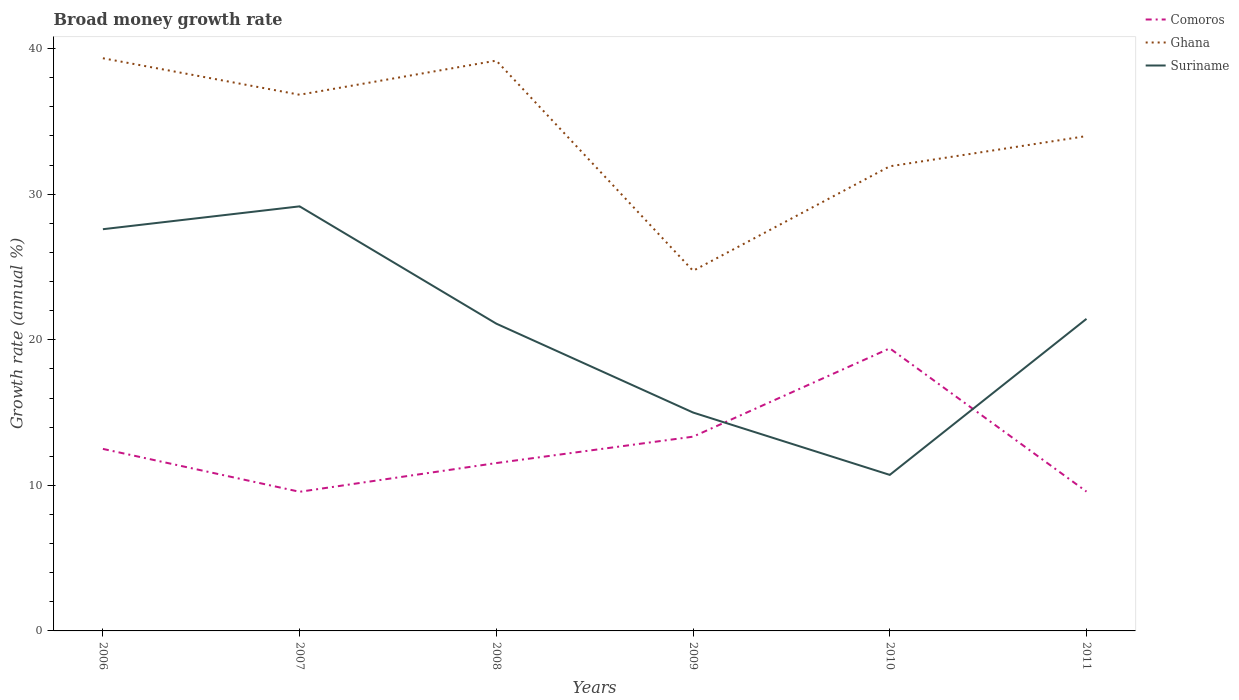Is the number of lines equal to the number of legend labels?
Offer a very short reply. Yes. Across all years, what is the maximum growth rate in Suriname?
Ensure brevity in your answer.  10.72. What is the total growth rate in Ghana in the graph?
Make the answer very short. 0.16. What is the difference between the highest and the second highest growth rate in Ghana?
Your answer should be very brief. 14.6. What is the difference between the highest and the lowest growth rate in Comoros?
Your answer should be very brief. 2. Is the growth rate in Ghana strictly greater than the growth rate in Suriname over the years?
Keep it short and to the point. No. Are the values on the major ticks of Y-axis written in scientific E-notation?
Offer a terse response. No. Does the graph contain any zero values?
Provide a succinct answer. No. How many legend labels are there?
Your answer should be compact. 3. What is the title of the graph?
Keep it short and to the point. Broad money growth rate. What is the label or title of the Y-axis?
Ensure brevity in your answer.  Growth rate (annual %). What is the Growth rate (annual %) in Comoros in 2006?
Provide a succinct answer. 12.5. What is the Growth rate (annual %) in Ghana in 2006?
Offer a terse response. 39.34. What is the Growth rate (annual %) in Suriname in 2006?
Offer a terse response. 27.6. What is the Growth rate (annual %) of Comoros in 2007?
Offer a very short reply. 9.56. What is the Growth rate (annual %) in Ghana in 2007?
Your answer should be very brief. 36.83. What is the Growth rate (annual %) of Suriname in 2007?
Offer a terse response. 29.17. What is the Growth rate (annual %) in Comoros in 2008?
Provide a succinct answer. 11.53. What is the Growth rate (annual %) of Ghana in 2008?
Ensure brevity in your answer.  39.18. What is the Growth rate (annual %) in Suriname in 2008?
Your answer should be compact. 21.11. What is the Growth rate (annual %) in Comoros in 2009?
Give a very brief answer. 13.34. What is the Growth rate (annual %) in Ghana in 2009?
Offer a very short reply. 24.74. What is the Growth rate (annual %) in Suriname in 2009?
Give a very brief answer. 15. What is the Growth rate (annual %) of Comoros in 2010?
Your answer should be compact. 19.41. What is the Growth rate (annual %) of Ghana in 2010?
Offer a very short reply. 31.92. What is the Growth rate (annual %) in Suriname in 2010?
Keep it short and to the point. 10.72. What is the Growth rate (annual %) in Comoros in 2011?
Ensure brevity in your answer.  9.57. What is the Growth rate (annual %) in Ghana in 2011?
Keep it short and to the point. 33.99. What is the Growth rate (annual %) in Suriname in 2011?
Ensure brevity in your answer.  21.44. Across all years, what is the maximum Growth rate (annual %) in Comoros?
Your answer should be compact. 19.41. Across all years, what is the maximum Growth rate (annual %) of Ghana?
Your response must be concise. 39.34. Across all years, what is the maximum Growth rate (annual %) in Suriname?
Give a very brief answer. 29.17. Across all years, what is the minimum Growth rate (annual %) of Comoros?
Offer a very short reply. 9.56. Across all years, what is the minimum Growth rate (annual %) of Ghana?
Give a very brief answer. 24.74. Across all years, what is the minimum Growth rate (annual %) of Suriname?
Your answer should be compact. 10.72. What is the total Growth rate (annual %) in Comoros in the graph?
Your answer should be compact. 75.92. What is the total Growth rate (annual %) in Ghana in the graph?
Your answer should be compact. 206. What is the total Growth rate (annual %) of Suriname in the graph?
Your answer should be very brief. 125.03. What is the difference between the Growth rate (annual %) in Comoros in 2006 and that in 2007?
Give a very brief answer. 2.95. What is the difference between the Growth rate (annual %) of Ghana in 2006 and that in 2007?
Ensure brevity in your answer.  2.51. What is the difference between the Growth rate (annual %) in Suriname in 2006 and that in 2007?
Provide a succinct answer. -1.57. What is the difference between the Growth rate (annual %) in Comoros in 2006 and that in 2008?
Your answer should be compact. 0.97. What is the difference between the Growth rate (annual %) of Ghana in 2006 and that in 2008?
Your answer should be very brief. 0.16. What is the difference between the Growth rate (annual %) in Suriname in 2006 and that in 2008?
Provide a short and direct response. 6.49. What is the difference between the Growth rate (annual %) in Comoros in 2006 and that in 2009?
Offer a very short reply. -0.84. What is the difference between the Growth rate (annual %) in Ghana in 2006 and that in 2009?
Your answer should be very brief. 14.6. What is the difference between the Growth rate (annual %) of Suriname in 2006 and that in 2009?
Give a very brief answer. 12.59. What is the difference between the Growth rate (annual %) in Comoros in 2006 and that in 2010?
Your response must be concise. -6.91. What is the difference between the Growth rate (annual %) in Ghana in 2006 and that in 2010?
Offer a very short reply. 7.42. What is the difference between the Growth rate (annual %) of Suriname in 2006 and that in 2010?
Offer a very short reply. 16.88. What is the difference between the Growth rate (annual %) of Comoros in 2006 and that in 2011?
Your response must be concise. 2.93. What is the difference between the Growth rate (annual %) in Ghana in 2006 and that in 2011?
Your response must be concise. 5.35. What is the difference between the Growth rate (annual %) of Suriname in 2006 and that in 2011?
Make the answer very short. 6.16. What is the difference between the Growth rate (annual %) of Comoros in 2007 and that in 2008?
Keep it short and to the point. -1.97. What is the difference between the Growth rate (annual %) of Ghana in 2007 and that in 2008?
Give a very brief answer. -2.34. What is the difference between the Growth rate (annual %) in Suriname in 2007 and that in 2008?
Keep it short and to the point. 8.06. What is the difference between the Growth rate (annual %) of Comoros in 2007 and that in 2009?
Offer a very short reply. -3.79. What is the difference between the Growth rate (annual %) in Ghana in 2007 and that in 2009?
Provide a succinct answer. 12.1. What is the difference between the Growth rate (annual %) of Suriname in 2007 and that in 2009?
Give a very brief answer. 14.16. What is the difference between the Growth rate (annual %) in Comoros in 2007 and that in 2010?
Ensure brevity in your answer.  -9.85. What is the difference between the Growth rate (annual %) of Ghana in 2007 and that in 2010?
Provide a succinct answer. 4.92. What is the difference between the Growth rate (annual %) of Suriname in 2007 and that in 2010?
Keep it short and to the point. 18.45. What is the difference between the Growth rate (annual %) of Comoros in 2007 and that in 2011?
Your answer should be compact. -0.01. What is the difference between the Growth rate (annual %) in Ghana in 2007 and that in 2011?
Offer a very short reply. 2.84. What is the difference between the Growth rate (annual %) in Suriname in 2007 and that in 2011?
Your answer should be very brief. 7.73. What is the difference between the Growth rate (annual %) of Comoros in 2008 and that in 2009?
Your answer should be compact. -1.81. What is the difference between the Growth rate (annual %) in Ghana in 2008 and that in 2009?
Keep it short and to the point. 14.44. What is the difference between the Growth rate (annual %) of Suriname in 2008 and that in 2009?
Provide a succinct answer. 6.1. What is the difference between the Growth rate (annual %) of Comoros in 2008 and that in 2010?
Make the answer very short. -7.88. What is the difference between the Growth rate (annual %) in Ghana in 2008 and that in 2010?
Offer a very short reply. 7.26. What is the difference between the Growth rate (annual %) in Suriname in 2008 and that in 2010?
Give a very brief answer. 10.39. What is the difference between the Growth rate (annual %) of Comoros in 2008 and that in 2011?
Offer a very short reply. 1.96. What is the difference between the Growth rate (annual %) of Ghana in 2008 and that in 2011?
Your response must be concise. 5.18. What is the difference between the Growth rate (annual %) of Suriname in 2008 and that in 2011?
Keep it short and to the point. -0.33. What is the difference between the Growth rate (annual %) in Comoros in 2009 and that in 2010?
Make the answer very short. -6.07. What is the difference between the Growth rate (annual %) of Ghana in 2009 and that in 2010?
Make the answer very short. -7.18. What is the difference between the Growth rate (annual %) in Suriname in 2009 and that in 2010?
Your response must be concise. 4.28. What is the difference between the Growth rate (annual %) in Comoros in 2009 and that in 2011?
Offer a very short reply. 3.77. What is the difference between the Growth rate (annual %) of Ghana in 2009 and that in 2011?
Your answer should be very brief. -9.26. What is the difference between the Growth rate (annual %) of Suriname in 2009 and that in 2011?
Your response must be concise. -6.43. What is the difference between the Growth rate (annual %) of Comoros in 2010 and that in 2011?
Provide a short and direct response. 9.84. What is the difference between the Growth rate (annual %) of Ghana in 2010 and that in 2011?
Offer a very short reply. -2.08. What is the difference between the Growth rate (annual %) of Suriname in 2010 and that in 2011?
Give a very brief answer. -10.72. What is the difference between the Growth rate (annual %) of Comoros in 2006 and the Growth rate (annual %) of Ghana in 2007?
Ensure brevity in your answer.  -24.33. What is the difference between the Growth rate (annual %) in Comoros in 2006 and the Growth rate (annual %) in Suriname in 2007?
Your answer should be very brief. -16.66. What is the difference between the Growth rate (annual %) in Ghana in 2006 and the Growth rate (annual %) in Suriname in 2007?
Ensure brevity in your answer.  10.17. What is the difference between the Growth rate (annual %) in Comoros in 2006 and the Growth rate (annual %) in Ghana in 2008?
Provide a short and direct response. -26.67. What is the difference between the Growth rate (annual %) in Comoros in 2006 and the Growth rate (annual %) in Suriname in 2008?
Your answer should be compact. -8.6. What is the difference between the Growth rate (annual %) in Ghana in 2006 and the Growth rate (annual %) in Suriname in 2008?
Your response must be concise. 18.23. What is the difference between the Growth rate (annual %) of Comoros in 2006 and the Growth rate (annual %) of Ghana in 2009?
Provide a succinct answer. -12.23. What is the difference between the Growth rate (annual %) in Comoros in 2006 and the Growth rate (annual %) in Suriname in 2009?
Make the answer very short. -2.5. What is the difference between the Growth rate (annual %) in Ghana in 2006 and the Growth rate (annual %) in Suriname in 2009?
Give a very brief answer. 24.34. What is the difference between the Growth rate (annual %) of Comoros in 2006 and the Growth rate (annual %) of Ghana in 2010?
Your answer should be very brief. -19.41. What is the difference between the Growth rate (annual %) in Comoros in 2006 and the Growth rate (annual %) in Suriname in 2010?
Offer a terse response. 1.78. What is the difference between the Growth rate (annual %) in Ghana in 2006 and the Growth rate (annual %) in Suriname in 2010?
Keep it short and to the point. 28.62. What is the difference between the Growth rate (annual %) of Comoros in 2006 and the Growth rate (annual %) of Ghana in 2011?
Offer a very short reply. -21.49. What is the difference between the Growth rate (annual %) in Comoros in 2006 and the Growth rate (annual %) in Suriname in 2011?
Provide a succinct answer. -8.93. What is the difference between the Growth rate (annual %) in Ghana in 2006 and the Growth rate (annual %) in Suriname in 2011?
Your answer should be compact. 17.9. What is the difference between the Growth rate (annual %) of Comoros in 2007 and the Growth rate (annual %) of Ghana in 2008?
Your response must be concise. -29.62. What is the difference between the Growth rate (annual %) in Comoros in 2007 and the Growth rate (annual %) in Suriname in 2008?
Ensure brevity in your answer.  -11.55. What is the difference between the Growth rate (annual %) of Ghana in 2007 and the Growth rate (annual %) of Suriname in 2008?
Make the answer very short. 15.73. What is the difference between the Growth rate (annual %) of Comoros in 2007 and the Growth rate (annual %) of Ghana in 2009?
Your answer should be very brief. -15.18. What is the difference between the Growth rate (annual %) in Comoros in 2007 and the Growth rate (annual %) in Suriname in 2009?
Give a very brief answer. -5.44. What is the difference between the Growth rate (annual %) in Ghana in 2007 and the Growth rate (annual %) in Suriname in 2009?
Offer a terse response. 21.83. What is the difference between the Growth rate (annual %) of Comoros in 2007 and the Growth rate (annual %) of Ghana in 2010?
Offer a terse response. -22.36. What is the difference between the Growth rate (annual %) in Comoros in 2007 and the Growth rate (annual %) in Suriname in 2010?
Keep it short and to the point. -1.16. What is the difference between the Growth rate (annual %) in Ghana in 2007 and the Growth rate (annual %) in Suriname in 2010?
Give a very brief answer. 26.12. What is the difference between the Growth rate (annual %) in Comoros in 2007 and the Growth rate (annual %) in Ghana in 2011?
Offer a terse response. -24.44. What is the difference between the Growth rate (annual %) in Comoros in 2007 and the Growth rate (annual %) in Suriname in 2011?
Make the answer very short. -11.88. What is the difference between the Growth rate (annual %) in Ghana in 2007 and the Growth rate (annual %) in Suriname in 2011?
Provide a short and direct response. 15.4. What is the difference between the Growth rate (annual %) of Comoros in 2008 and the Growth rate (annual %) of Ghana in 2009?
Your answer should be very brief. -13.21. What is the difference between the Growth rate (annual %) of Comoros in 2008 and the Growth rate (annual %) of Suriname in 2009?
Offer a very short reply. -3.47. What is the difference between the Growth rate (annual %) in Ghana in 2008 and the Growth rate (annual %) in Suriname in 2009?
Offer a terse response. 24.18. What is the difference between the Growth rate (annual %) of Comoros in 2008 and the Growth rate (annual %) of Ghana in 2010?
Offer a terse response. -20.39. What is the difference between the Growth rate (annual %) in Comoros in 2008 and the Growth rate (annual %) in Suriname in 2010?
Provide a short and direct response. 0.81. What is the difference between the Growth rate (annual %) in Ghana in 2008 and the Growth rate (annual %) in Suriname in 2010?
Your answer should be compact. 28.46. What is the difference between the Growth rate (annual %) of Comoros in 2008 and the Growth rate (annual %) of Ghana in 2011?
Make the answer very short. -22.46. What is the difference between the Growth rate (annual %) of Comoros in 2008 and the Growth rate (annual %) of Suriname in 2011?
Your answer should be compact. -9.91. What is the difference between the Growth rate (annual %) in Ghana in 2008 and the Growth rate (annual %) in Suriname in 2011?
Offer a very short reply. 17.74. What is the difference between the Growth rate (annual %) in Comoros in 2009 and the Growth rate (annual %) in Ghana in 2010?
Make the answer very short. -18.57. What is the difference between the Growth rate (annual %) in Comoros in 2009 and the Growth rate (annual %) in Suriname in 2010?
Make the answer very short. 2.63. What is the difference between the Growth rate (annual %) of Ghana in 2009 and the Growth rate (annual %) of Suriname in 2010?
Provide a succinct answer. 14.02. What is the difference between the Growth rate (annual %) in Comoros in 2009 and the Growth rate (annual %) in Ghana in 2011?
Your answer should be compact. -20.65. What is the difference between the Growth rate (annual %) of Comoros in 2009 and the Growth rate (annual %) of Suriname in 2011?
Ensure brevity in your answer.  -8.09. What is the difference between the Growth rate (annual %) of Ghana in 2009 and the Growth rate (annual %) of Suriname in 2011?
Ensure brevity in your answer.  3.3. What is the difference between the Growth rate (annual %) of Comoros in 2010 and the Growth rate (annual %) of Ghana in 2011?
Keep it short and to the point. -14.58. What is the difference between the Growth rate (annual %) of Comoros in 2010 and the Growth rate (annual %) of Suriname in 2011?
Provide a succinct answer. -2.03. What is the difference between the Growth rate (annual %) in Ghana in 2010 and the Growth rate (annual %) in Suriname in 2011?
Ensure brevity in your answer.  10.48. What is the average Growth rate (annual %) of Comoros per year?
Provide a short and direct response. 12.65. What is the average Growth rate (annual %) in Ghana per year?
Provide a succinct answer. 34.33. What is the average Growth rate (annual %) of Suriname per year?
Offer a very short reply. 20.84. In the year 2006, what is the difference between the Growth rate (annual %) in Comoros and Growth rate (annual %) in Ghana?
Make the answer very short. -26.84. In the year 2006, what is the difference between the Growth rate (annual %) of Comoros and Growth rate (annual %) of Suriname?
Keep it short and to the point. -15.09. In the year 2006, what is the difference between the Growth rate (annual %) of Ghana and Growth rate (annual %) of Suriname?
Provide a succinct answer. 11.74. In the year 2007, what is the difference between the Growth rate (annual %) of Comoros and Growth rate (annual %) of Ghana?
Your answer should be very brief. -27.28. In the year 2007, what is the difference between the Growth rate (annual %) of Comoros and Growth rate (annual %) of Suriname?
Offer a very short reply. -19.61. In the year 2007, what is the difference between the Growth rate (annual %) of Ghana and Growth rate (annual %) of Suriname?
Give a very brief answer. 7.67. In the year 2008, what is the difference between the Growth rate (annual %) in Comoros and Growth rate (annual %) in Ghana?
Your answer should be compact. -27.65. In the year 2008, what is the difference between the Growth rate (annual %) in Comoros and Growth rate (annual %) in Suriname?
Offer a very short reply. -9.58. In the year 2008, what is the difference between the Growth rate (annual %) of Ghana and Growth rate (annual %) of Suriname?
Make the answer very short. 18.07. In the year 2009, what is the difference between the Growth rate (annual %) of Comoros and Growth rate (annual %) of Ghana?
Make the answer very short. -11.39. In the year 2009, what is the difference between the Growth rate (annual %) in Comoros and Growth rate (annual %) in Suriname?
Your answer should be very brief. -1.66. In the year 2009, what is the difference between the Growth rate (annual %) in Ghana and Growth rate (annual %) in Suriname?
Provide a short and direct response. 9.74. In the year 2010, what is the difference between the Growth rate (annual %) of Comoros and Growth rate (annual %) of Ghana?
Keep it short and to the point. -12.51. In the year 2010, what is the difference between the Growth rate (annual %) of Comoros and Growth rate (annual %) of Suriname?
Your response must be concise. 8.69. In the year 2010, what is the difference between the Growth rate (annual %) in Ghana and Growth rate (annual %) in Suriname?
Provide a short and direct response. 21.2. In the year 2011, what is the difference between the Growth rate (annual %) of Comoros and Growth rate (annual %) of Ghana?
Keep it short and to the point. -24.42. In the year 2011, what is the difference between the Growth rate (annual %) in Comoros and Growth rate (annual %) in Suriname?
Provide a succinct answer. -11.87. In the year 2011, what is the difference between the Growth rate (annual %) of Ghana and Growth rate (annual %) of Suriname?
Provide a short and direct response. 12.56. What is the ratio of the Growth rate (annual %) in Comoros in 2006 to that in 2007?
Your response must be concise. 1.31. What is the ratio of the Growth rate (annual %) of Ghana in 2006 to that in 2007?
Provide a short and direct response. 1.07. What is the ratio of the Growth rate (annual %) of Suriname in 2006 to that in 2007?
Your response must be concise. 0.95. What is the ratio of the Growth rate (annual %) in Comoros in 2006 to that in 2008?
Give a very brief answer. 1.08. What is the ratio of the Growth rate (annual %) of Suriname in 2006 to that in 2008?
Your answer should be very brief. 1.31. What is the ratio of the Growth rate (annual %) of Comoros in 2006 to that in 2009?
Ensure brevity in your answer.  0.94. What is the ratio of the Growth rate (annual %) of Ghana in 2006 to that in 2009?
Your answer should be very brief. 1.59. What is the ratio of the Growth rate (annual %) of Suriname in 2006 to that in 2009?
Provide a short and direct response. 1.84. What is the ratio of the Growth rate (annual %) in Comoros in 2006 to that in 2010?
Keep it short and to the point. 0.64. What is the ratio of the Growth rate (annual %) of Ghana in 2006 to that in 2010?
Give a very brief answer. 1.23. What is the ratio of the Growth rate (annual %) of Suriname in 2006 to that in 2010?
Ensure brevity in your answer.  2.57. What is the ratio of the Growth rate (annual %) in Comoros in 2006 to that in 2011?
Ensure brevity in your answer.  1.31. What is the ratio of the Growth rate (annual %) in Ghana in 2006 to that in 2011?
Your answer should be compact. 1.16. What is the ratio of the Growth rate (annual %) in Suriname in 2006 to that in 2011?
Provide a succinct answer. 1.29. What is the ratio of the Growth rate (annual %) of Comoros in 2007 to that in 2008?
Provide a short and direct response. 0.83. What is the ratio of the Growth rate (annual %) of Ghana in 2007 to that in 2008?
Keep it short and to the point. 0.94. What is the ratio of the Growth rate (annual %) in Suriname in 2007 to that in 2008?
Make the answer very short. 1.38. What is the ratio of the Growth rate (annual %) of Comoros in 2007 to that in 2009?
Give a very brief answer. 0.72. What is the ratio of the Growth rate (annual %) of Ghana in 2007 to that in 2009?
Keep it short and to the point. 1.49. What is the ratio of the Growth rate (annual %) of Suriname in 2007 to that in 2009?
Provide a short and direct response. 1.94. What is the ratio of the Growth rate (annual %) in Comoros in 2007 to that in 2010?
Offer a terse response. 0.49. What is the ratio of the Growth rate (annual %) of Ghana in 2007 to that in 2010?
Provide a succinct answer. 1.15. What is the ratio of the Growth rate (annual %) in Suriname in 2007 to that in 2010?
Keep it short and to the point. 2.72. What is the ratio of the Growth rate (annual %) of Ghana in 2007 to that in 2011?
Your response must be concise. 1.08. What is the ratio of the Growth rate (annual %) in Suriname in 2007 to that in 2011?
Your response must be concise. 1.36. What is the ratio of the Growth rate (annual %) of Comoros in 2008 to that in 2009?
Your response must be concise. 0.86. What is the ratio of the Growth rate (annual %) in Ghana in 2008 to that in 2009?
Keep it short and to the point. 1.58. What is the ratio of the Growth rate (annual %) of Suriname in 2008 to that in 2009?
Ensure brevity in your answer.  1.41. What is the ratio of the Growth rate (annual %) of Comoros in 2008 to that in 2010?
Provide a short and direct response. 0.59. What is the ratio of the Growth rate (annual %) of Ghana in 2008 to that in 2010?
Ensure brevity in your answer.  1.23. What is the ratio of the Growth rate (annual %) of Suriname in 2008 to that in 2010?
Give a very brief answer. 1.97. What is the ratio of the Growth rate (annual %) of Comoros in 2008 to that in 2011?
Your answer should be compact. 1.2. What is the ratio of the Growth rate (annual %) of Ghana in 2008 to that in 2011?
Offer a very short reply. 1.15. What is the ratio of the Growth rate (annual %) in Suriname in 2008 to that in 2011?
Offer a terse response. 0.98. What is the ratio of the Growth rate (annual %) in Comoros in 2009 to that in 2010?
Ensure brevity in your answer.  0.69. What is the ratio of the Growth rate (annual %) of Ghana in 2009 to that in 2010?
Your response must be concise. 0.78. What is the ratio of the Growth rate (annual %) of Suriname in 2009 to that in 2010?
Your answer should be compact. 1.4. What is the ratio of the Growth rate (annual %) of Comoros in 2009 to that in 2011?
Your answer should be very brief. 1.39. What is the ratio of the Growth rate (annual %) of Ghana in 2009 to that in 2011?
Offer a terse response. 0.73. What is the ratio of the Growth rate (annual %) of Suriname in 2009 to that in 2011?
Offer a terse response. 0.7. What is the ratio of the Growth rate (annual %) in Comoros in 2010 to that in 2011?
Offer a terse response. 2.03. What is the ratio of the Growth rate (annual %) in Ghana in 2010 to that in 2011?
Provide a short and direct response. 0.94. What is the ratio of the Growth rate (annual %) in Suriname in 2010 to that in 2011?
Provide a succinct answer. 0.5. What is the difference between the highest and the second highest Growth rate (annual %) of Comoros?
Provide a succinct answer. 6.07. What is the difference between the highest and the second highest Growth rate (annual %) in Ghana?
Give a very brief answer. 0.16. What is the difference between the highest and the second highest Growth rate (annual %) of Suriname?
Give a very brief answer. 1.57. What is the difference between the highest and the lowest Growth rate (annual %) of Comoros?
Keep it short and to the point. 9.85. What is the difference between the highest and the lowest Growth rate (annual %) of Ghana?
Ensure brevity in your answer.  14.6. What is the difference between the highest and the lowest Growth rate (annual %) of Suriname?
Make the answer very short. 18.45. 